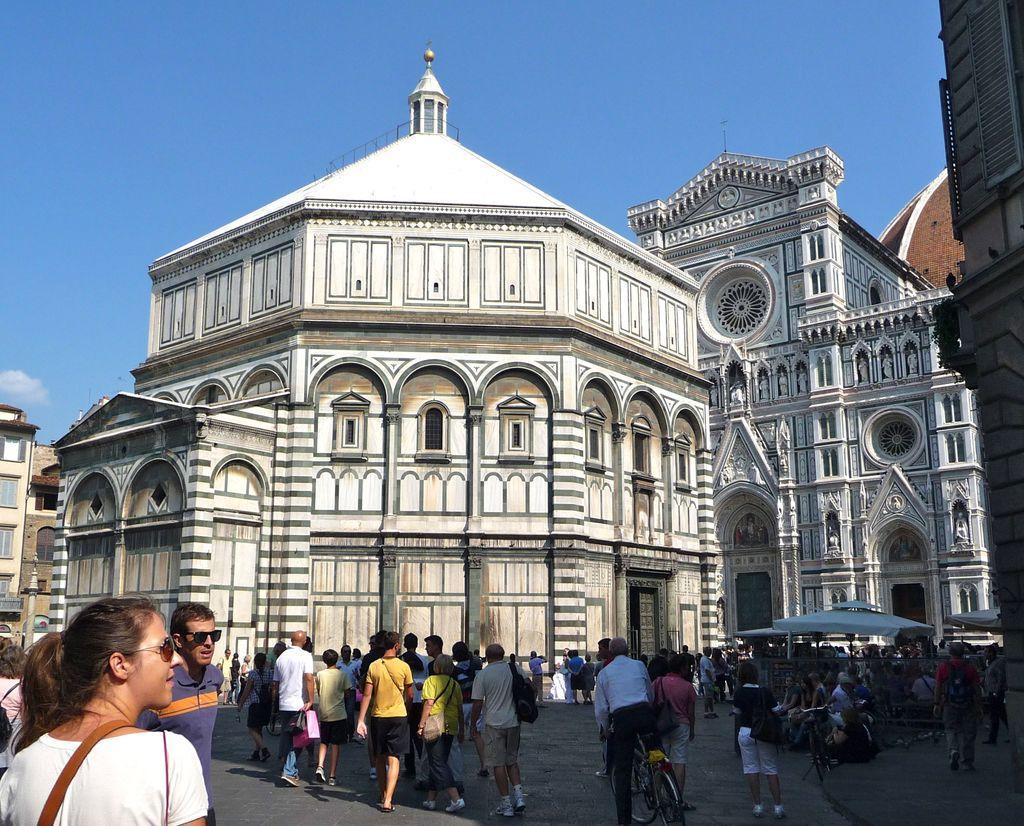Could you give a brief overview of what you see in this image? In this picture I can see a few people standing on the surface. I can see a few people sitting on the surface. I can see bicycles. I can see tents on the right side. I can see the buildings. I can see clouds in the sky. 